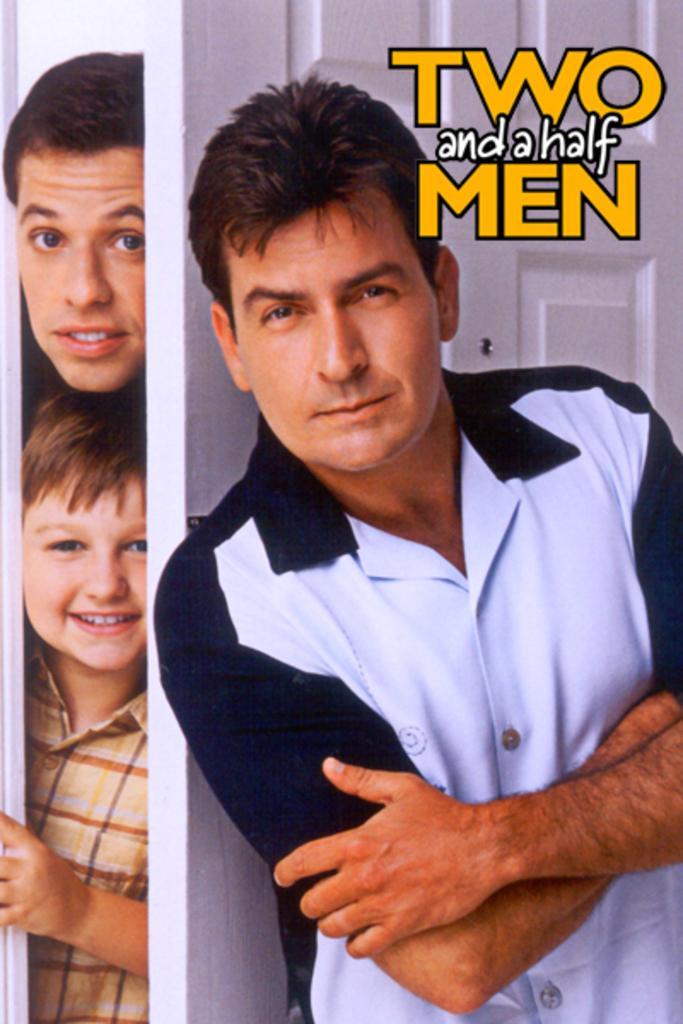Can you describe this image briefly? This is a poster. In this image there is a man standing. On the left side of the image there are two people behind the door. At the top there is text. 